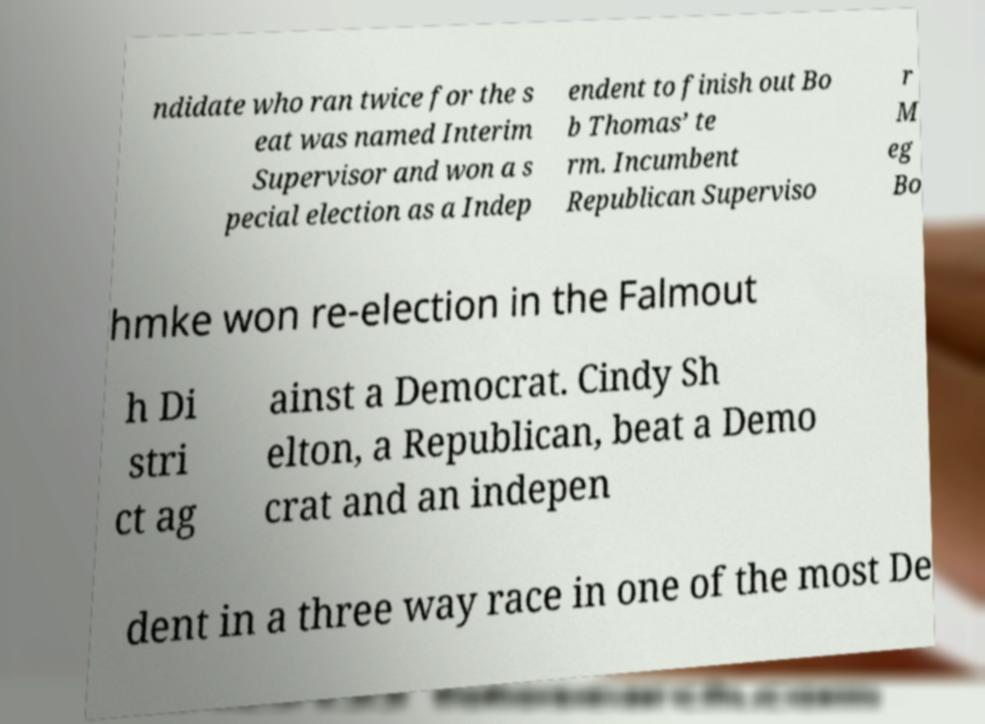For documentation purposes, I need the text within this image transcribed. Could you provide that? ndidate who ran twice for the s eat was named Interim Supervisor and won a s pecial election as a Indep endent to finish out Bo b Thomas’ te rm. Incumbent Republican Superviso r M eg Bo hmke won re-election in the Falmout h Di stri ct ag ainst a Democrat. Cindy Sh elton, a Republican, beat a Demo crat and an indepen dent in a three way race in one of the most De 